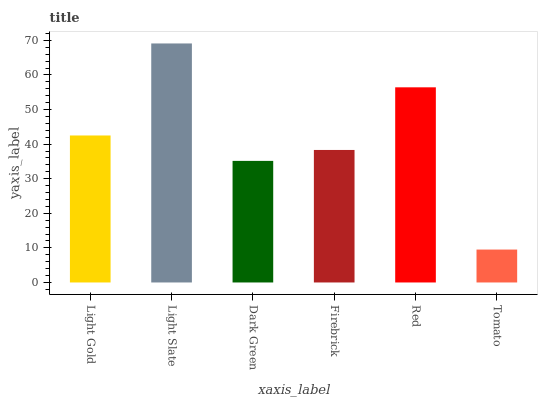Is Dark Green the minimum?
Answer yes or no. No. Is Dark Green the maximum?
Answer yes or no. No. Is Light Slate greater than Dark Green?
Answer yes or no. Yes. Is Dark Green less than Light Slate?
Answer yes or no. Yes. Is Dark Green greater than Light Slate?
Answer yes or no. No. Is Light Slate less than Dark Green?
Answer yes or no. No. Is Light Gold the high median?
Answer yes or no. Yes. Is Firebrick the low median?
Answer yes or no. Yes. Is Red the high median?
Answer yes or no. No. Is Red the low median?
Answer yes or no. No. 